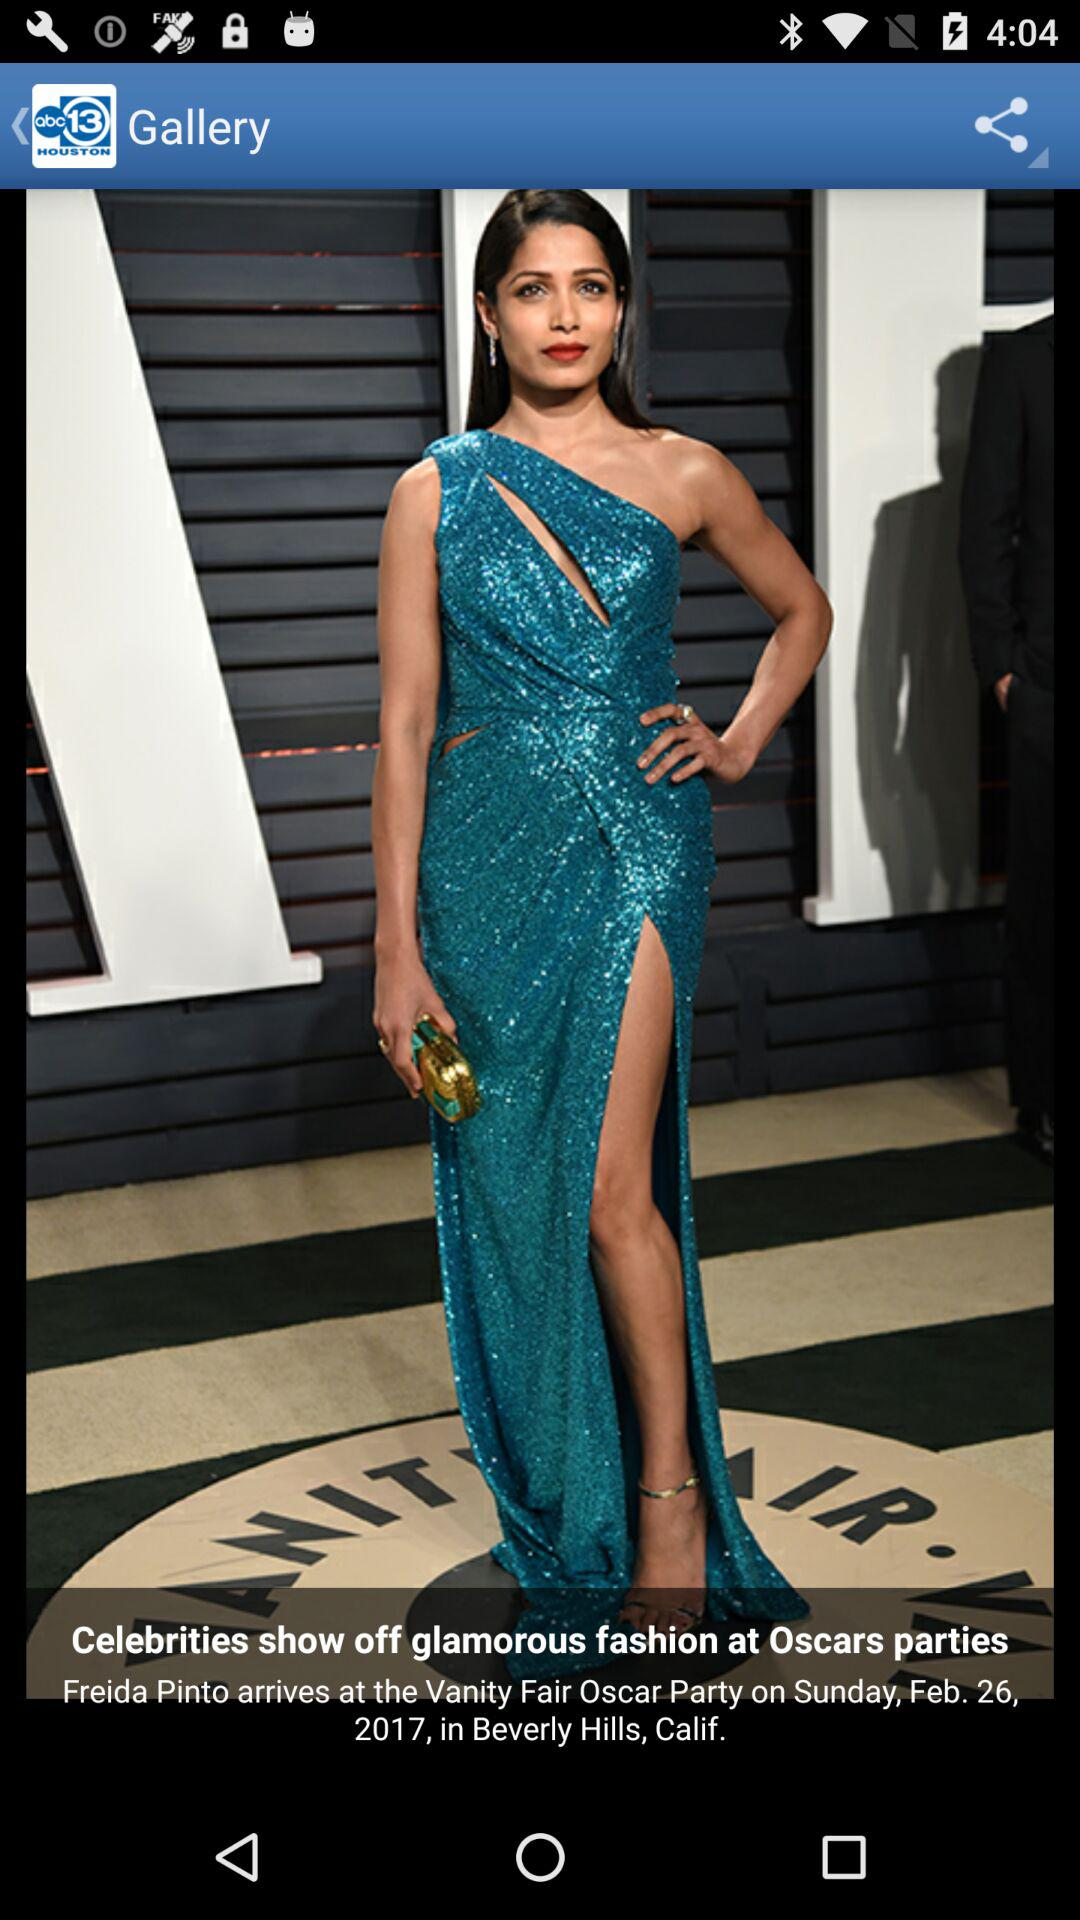What is the date of the "Oscar Party"? The date of the "Oscar Party" is Sunday, February 26, 2017. 